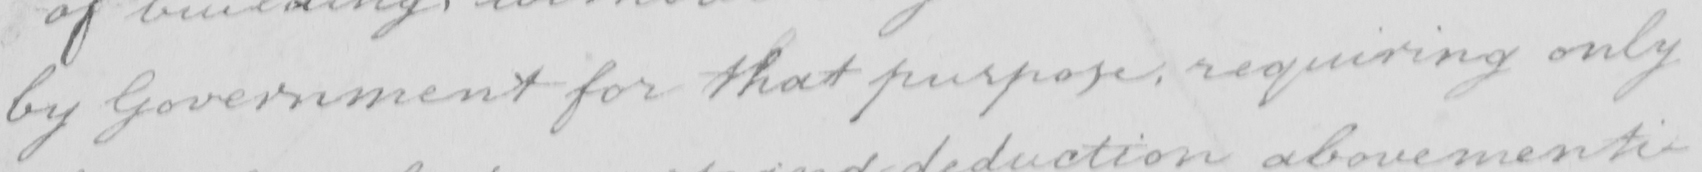What text is written in this handwritten line? by Government for what purpose , requiring only 